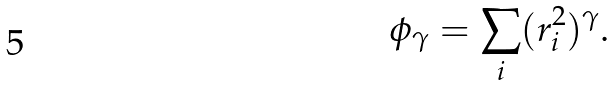<formula> <loc_0><loc_0><loc_500><loc_500>\phi _ { \gamma } = \sum _ { i } ( { r _ { i } ^ { 2 } } ) ^ { \gamma } .</formula> 